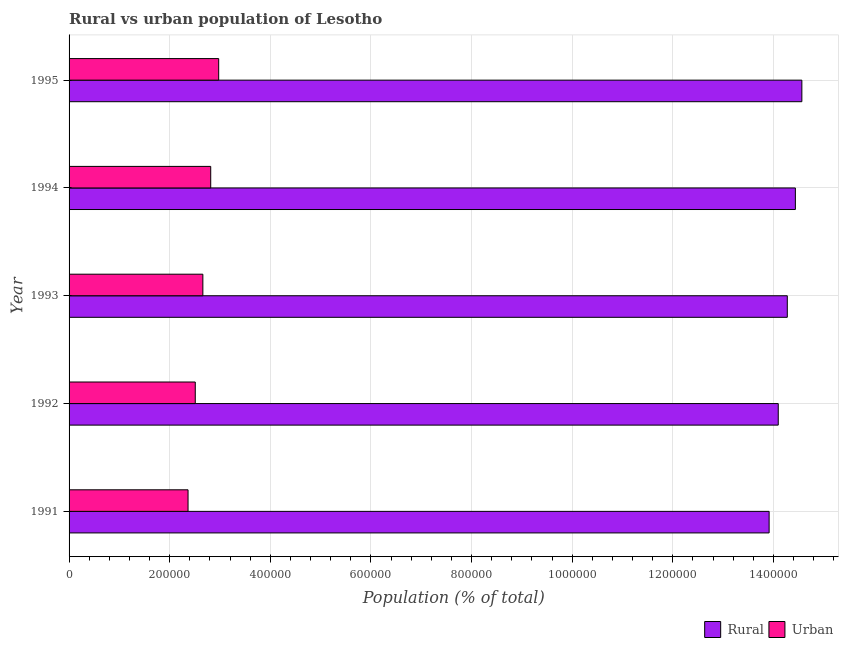How many groups of bars are there?
Your answer should be compact. 5. How many bars are there on the 5th tick from the top?
Offer a very short reply. 2. In how many cases, is the number of bars for a given year not equal to the number of legend labels?
Your answer should be compact. 0. What is the urban population density in 1991?
Your response must be concise. 2.36e+05. Across all years, what is the maximum rural population density?
Your answer should be compact. 1.46e+06. Across all years, what is the minimum rural population density?
Offer a terse response. 1.39e+06. What is the total urban population density in the graph?
Provide a succinct answer. 1.33e+06. What is the difference between the rural population density in 1992 and that in 1995?
Keep it short and to the point. -4.69e+04. What is the difference between the urban population density in 1995 and the rural population density in 1993?
Your answer should be very brief. -1.13e+06. What is the average urban population density per year?
Give a very brief answer. 2.66e+05. In the year 1994, what is the difference between the rural population density and urban population density?
Offer a very short reply. 1.16e+06. In how many years, is the rural population density greater than 1040000 %?
Keep it short and to the point. 5. What is the ratio of the rural population density in 1993 to that in 1995?
Your answer should be compact. 0.98. What is the difference between the highest and the second highest rural population density?
Offer a terse response. 1.29e+04. What is the difference between the highest and the lowest rural population density?
Provide a short and direct response. 6.50e+04. In how many years, is the urban population density greater than the average urban population density taken over all years?
Your response must be concise. 2. Is the sum of the urban population density in 1994 and 1995 greater than the maximum rural population density across all years?
Your response must be concise. No. What does the 1st bar from the top in 1991 represents?
Offer a terse response. Urban. What does the 1st bar from the bottom in 1993 represents?
Ensure brevity in your answer.  Rural. Are all the bars in the graph horizontal?
Offer a terse response. Yes. How many years are there in the graph?
Give a very brief answer. 5. What is the difference between two consecutive major ticks on the X-axis?
Your response must be concise. 2.00e+05. Are the values on the major ticks of X-axis written in scientific E-notation?
Your answer should be compact. No. Where does the legend appear in the graph?
Ensure brevity in your answer.  Bottom right. How many legend labels are there?
Provide a succinct answer. 2. How are the legend labels stacked?
Give a very brief answer. Horizontal. What is the title of the graph?
Provide a succinct answer. Rural vs urban population of Lesotho. What is the label or title of the X-axis?
Ensure brevity in your answer.  Population (% of total). What is the label or title of the Y-axis?
Offer a terse response. Year. What is the Population (% of total) in Rural in 1991?
Your answer should be compact. 1.39e+06. What is the Population (% of total) of Urban in 1991?
Give a very brief answer. 2.36e+05. What is the Population (% of total) in Rural in 1992?
Give a very brief answer. 1.41e+06. What is the Population (% of total) in Urban in 1992?
Offer a terse response. 2.51e+05. What is the Population (% of total) in Rural in 1993?
Keep it short and to the point. 1.43e+06. What is the Population (% of total) of Urban in 1993?
Provide a short and direct response. 2.66e+05. What is the Population (% of total) in Rural in 1994?
Offer a very short reply. 1.44e+06. What is the Population (% of total) of Urban in 1994?
Ensure brevity in your answer.  2.82e+05. What is the Population (% of total) of Rural in 1995?
Your answer should be compact. 1.46e+06. What is the Population (% of total) of Urban in 1995?
Ensure brevity in your answer.  2.97e+05. Across all years, what is the maximum Population (% of total) in Rural?
Give a very brief answer. 1.46e+06. Across all years, what is the maximum Population (% of total) in Urban?
Provide a short and direct response. 2.97e+05. Across all years, what is the minimum Population (% of total) of Rural?
Ensure brevity in your answer.  1.39e+06. Across all years, what is the minimum Population (% of total) of Urban?
Provide a succinct answer. 2.36e+05. What is the total Population (% of total) in Rural in the graph?
Offer a terse response. 7.13e+06. What is the total Population (% of total) of Urban in the graph?
Your response must be concise. 1.33e+06. What is the difference between the Population (% of total) of Rural in 1991 and that in 1992?
Your answer should be compact. -1.81e+04. What is the difference between the Population (% of total) in Urban in 1991 and that in 1992?
Offer a terse response. -1.43e+04. What is the difference between the Population (% of total) of Rural in 1991 and that in 1993?
Your answer should be very brief. -3.61e+04. What is the difference between the Population (% of total) in Urban in 1991 and that in 1993?
Your answer should be very brief. -2.94e+04. What is the difference between the Population (% of total) in Rural in 1991 and that in 1994?
Offer a terse response. -5.22e+04. What is the difference between the Population (% of total) of Urban in 1991 and that in 1994?
Provide a succinct answer. -4.50e+04. What is the difference between the Population (% of total) of Rural in 1991 and that in 1995?
Your answer should be compact. -6.50e+04. What is the difference between the Population (% of total) of Urban in 1991 and that in 1995?
Keep it short and to the point. -6.09e+04. What is the difference between the Population (% of total) of Rural in 1992 and that in 1993?
Offer a very short reply. -1.80e+04. What is the difference between the Population (% of total) in Urban in 1992 and that in 1993?
Give a very brief answer. -1.51e+04. What is the difference between the Population (% of total) in Rural in 1992 and that in 1994?
Provide a short and direct response. -3.40e+04. What is the difference between the Population (% of total) in Urban in 1992 and that in 1994?
Keep it short and to the point. -3.07e+04. What is the difference between the Population (% of total) in Rural in 1992 and that in 1995?
Provide a succinct answer. -4.69e+04. What is the difference between the Population (% of total) of Urban in 1992 and that in 1995?
Ensure brevity in your answer.  -4.65e+04. What is the difference between the Population (% of total) in Rural in 1993 and that in 1994?
Provide a short and direct response. -1.61e+04. What is the difference between the Population (% of total) of Urban in 1993 and that in 1994?
Provide a succinct answer. -1.56e+04. What is the difference between the Population (% of total) in Rural in 1993 and that in 1995?
Your response must be concise. -2.89e+04. What is the difference between the Population (% of total) in Urban in 1993 and that in 1995?
Give a very brief answer. -3.14e+04. What is the difference between the Population (% of total) in Rural in 1994 and that in 1995?
Offer a terse response. -1.29e+04. What is the difference between the Population (% of total) of Urban in 1994 and that in 1995?
Offer a terse response. -1.58e+04. What is the difference between the Population (% of total) in Rural in 1991 and the Population (% of total) in Urban in 1992?
Offer a terse response. 1.14e+06. What is the difference between the Population (% of total) in Rural in 1991 and the Population (% of total) in Urban in 1993?
Ensure brevity in your answer.  1.13e+06. What is the difference between the Population (% of total) in Rural in 1991 and the Population (% of total) in Urban in 1994?
Provide a short and direct response. 1.11e+06. What is the difference between the Population (% of total) of Rural in 1991 and the Population (% of total) of Urban in 1995?
Ensure brevity in your answer.  1.09e+06. What is the difference between the Population (% of total) of Rural in 1992 and the Population (% of total) of Urban in 1993?
Your answer should be compact. 1.14e+06. What is the difference between the Population (% of total) in Rural in 1992 and the Population (% of total) in Urban in 1994?
Make the answer very short. 1.13e+06. What is the difference between the Population (% of total) in Rural in 1992 and the Population (% of total) in Urban in 1995?
Your answer should be very brief. 1.11e+06. What is the difference between the Population (% of total) of Rural in 1993 and the Population (% of total) of Urban in 1994?
Ensure brevity in your answer.  1.15e+06. What is the difference between the Population (% of total) of Rural in 1993 and the Population (% of total) of Urban in 1995?
Your answer should be compact. 1.13e+06. What is the difference between the Population (% of total) of Rural in 1994 and the Population (% of total) of Urban in 1995?
Provide a succinct answer. 1.15e+06. What is the average Population (% of total) of Rural per year?
Provide a succinct answer. 1.43e+06. What is the average Population (% of total) of Urban per year?
Offer a very short reply. 2.66e+05. In the year 1991, what is the difference between the Population (% of total) in Rural and Population (% of total) in Urban?
Make the answer very short. 1.15e+06. In the year 1992, what is the difference between the Population (% of total) in Rural and Population (% of total) in Urban?
Offer a terse response. 1.16e+06. In the year 1993, what is the difference between the Population (% of total) of Rural and Population (% of total) of Urban?
Ensure brevity in your answer.  1.16e+06. In the year 1994, what is the difference between the Population (% of total) in Rural and Population (% of total) in Urban?
Offer a terse response. 1.16e+06. In the year 1995, what is the difference between the Population (% of total) in Rural and Population (% of total) in Urban?
Provide a short and direct response. 1.16e+06. What is the ratio of the Population (% of total) of Rural in 1991 to that in 1992?
Your answer should be very brief. 0.99. What is the ratio of the Population (% of total) of Urban in 1991 to that in 1992?
Your answer should be very brief. 0.94. What is the ratio of the Population (% of total) in Rural in 1991 to that in 1993?
Your answer should be very brief. 0.97. What is the ratio of the Population (% of total) in Urban in 1991 to that in 1993?
Ensure brevity in your answer.  0.89. What is the ratio of the Population (% of total) of Rural in 1991 to that in 1994?
Your answer should be compact. 0.96. What is the ratio of the Population (% of total) of Urban in 1991 to that in 1994?
Make the answer very short. 0.84. What is the ratio of the Population (% of total) in Rural in 1991 to that in 1995?
Offer a terse response. 0.96. What is the ratio of the Population (% of total) of Urban in 1991 to that in 1995?
Your answer should be very brief. 0.8. What is the ratio of the Population (% of total) in Rural in 1992 to that in 1993?
Provide a succinct answer. 0.99. What is the ratio of the Population (% of total) in Urban in 1992 to that in 1993?
Offer a terse response. 0.94. What is the ratio of the Population (% of total) in Rural in 1992 to that in 1994?
Your answer should be compact. 0.98. What is the ratio of the Population (% of total) of Urban in 1992 to that in 1994?
Make the answer very short. 0.89. What is the ratio of the Population (% of total) of Rural in 1992 to that in 1995?
Your answer should be compact. 0.97. What is the ratio of the Population (% of total) in Urban in 1992 to that in 1995?
Offer a very short reply. 0.84. What is the ratio of the Population (% of total) in Rural in 1993 to that in 1994?
Make the answer very short. 0.99. What is the ratio of the Population (% of total) of Urban in 1993 to that in 1994?
Your answer should be very brief. 0.94. What is the ratio of the Population (% of total) in Rural in 1993 to that in 1995?
Offer a very short reply. 0.98. What is the ratio of the Population (% of total) of Urban in 1993 to that in 1995?
Give a very brief answer. 0.89. What is the ratio of the Population (% of total) of Urban in 1994 to that in 1995?
Provide a short and direct response. 0.95. What is the difference between the highest and the second highest Population (% of total) in Rural?
Provide a short and direct response. 1.29e+04. What is the difference between the highest and the second highest Population (% of total) of Urban?
Ensure brevity in your answer.  1.58e+04. What is the difference between the highest and the lowest Population (% of total) in Rural?
Ensure brevity in your answer.  6.50e+04. What is the difference between the highest and the lowest Population (% of total) in Urban?
Ensure brevity in your answer.  6.09e+04. 